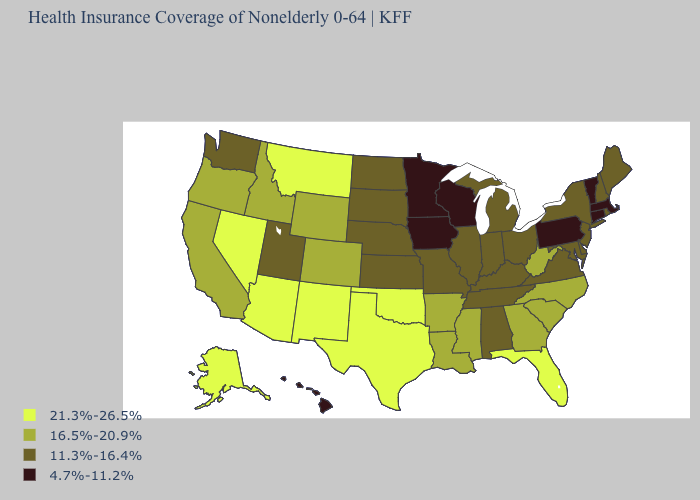What is the value of Kentucky?
Concise answer only. 11.3%-16.4%. Among the states that border Pennsylvania , does West Virginia have the highest value?
Give a very brief answer. Yes. Which states have the lowest value in the USA?
Quick response, please. Connecticut, Hawaii, Iowa, Massachusetts, Minnesota, Pennsylvania, Vermont, Wisconsin. How many symbols are there in the legend?
Short answer required. 4. Name the states that have a value in the range 16.5%-20.9%?
Quick response, please. Arkansas, California, Colorado, Georgia, Idaho, Louisiana, Mississippi, North Carolina, Oregon, South Carolina, West Virginia, Wyoming. What is the value of Kentucky?
Quick response, please. 11.3%-16.4%. Among the states that border Texas , does Oklahoma have the highest value?
Give a very brief answer. Yes. Name the states that have a value in the range 11.3%-16.4%?
Keep it brief. Alabama, Delaware, Illinois, Indiana, Kansas, Kentucky, Maine, Maryland, Michigan, Missouri, Nebraska, New Hampshire, New Jersey, New York, North Dakota, Ohio, Rhode Island, South Dakota, Tennessee, Utah, Virginia, Washington. Does the map have missing data?
Keep it brief. No. Which states hav the highest value in the MidWest?
Quick response, please. Illinois, Indiana, Kansas, Michigan, Missouri, Nebraska, North Dakota, Ohio, South Dakota. What is the value of Kentucky?
Short answer required. 11.3%-16.4%. Which states have the lowest value in the Northeast?
Answer briefly. Connecticut, Massachusetts, Pennsylvania, Vermont. What is the value of Vermont?
Write a very short answer. 4.7%-11.2%. What is the lowest value in the USA?
Quick response, please. 4.7%-11.2%. Among the states that border Missouri , does Tennessee have the highest value?
Keep it brief. No. 